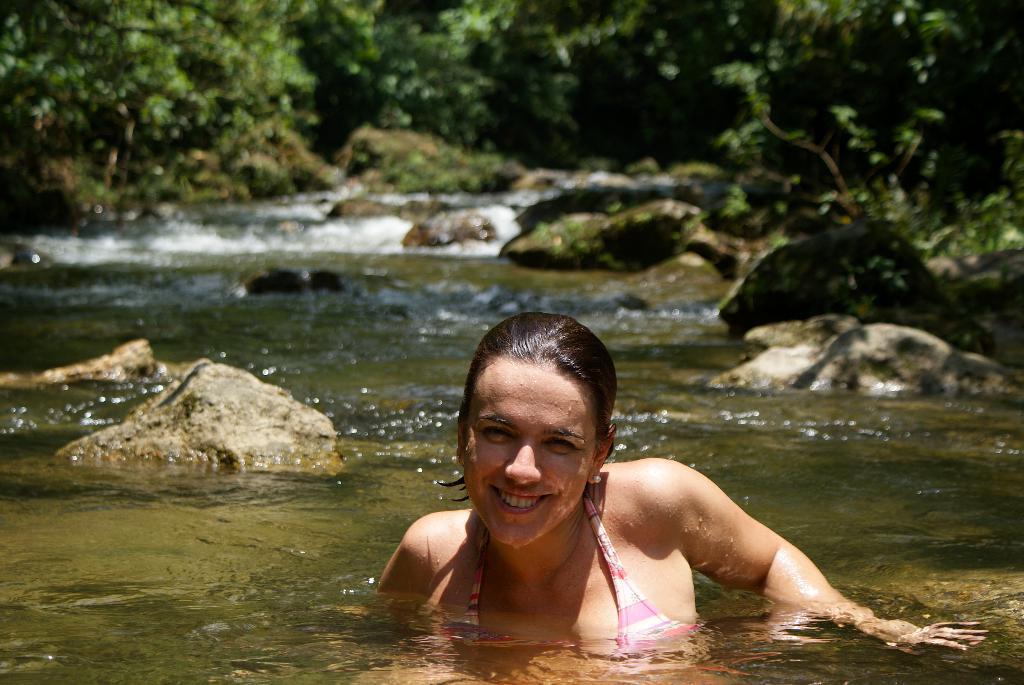How would you summarize this image in a sentence or two? In this picture there is a girl in the center of the image, in the water and there are rocks and trees in the background area of the image. 